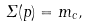<formula> <loc_0><loc_0><loc_500><loc_500>\Sigma ( p ) = m _ { c } ,</formula> 